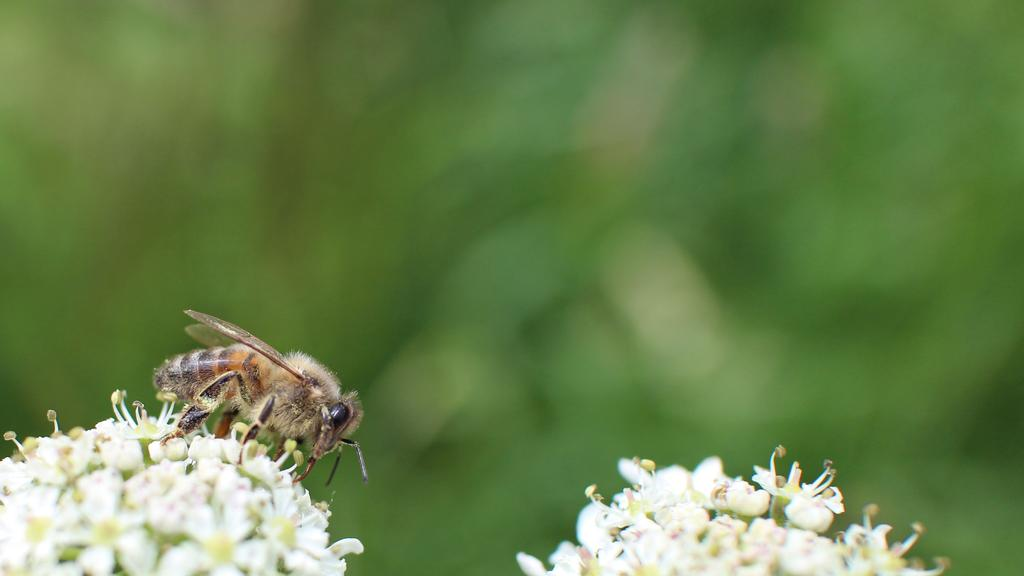What is present on the left side of the image? There is an insect on a flower on the left side of the image. Are there any other flowers visible in the image? Yes, there is another flower beside the insect. Can you describe the background of the image? The background of the image is blurry. How many chances does the insect have to reach the limit in the image? There is no reference to a limit or chances in the image, as it features an insect on a flower and another flower beside it. 